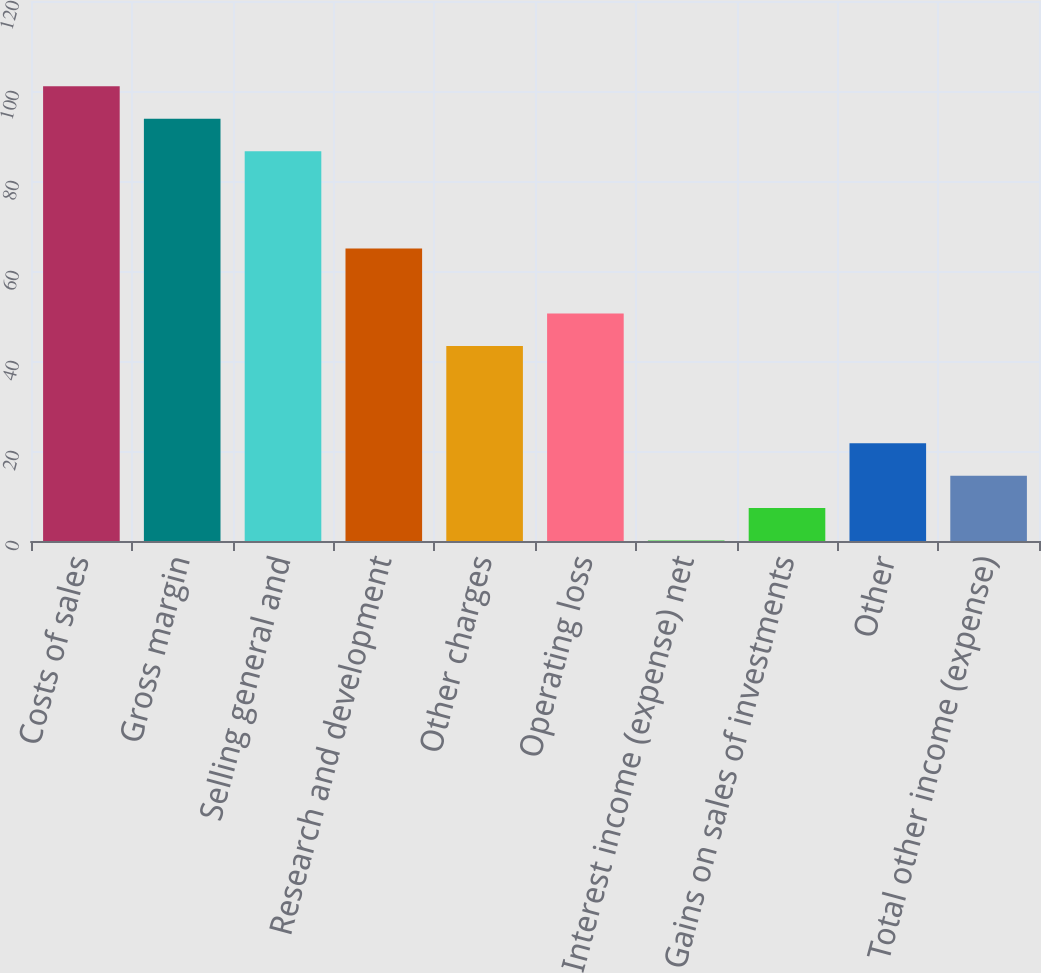Convert chart. <chart><loc_0><loc_0><loc_500><loc_500><bar_chart><fcel>Costs of sales<fcel>Gross margin<fcel>Selling general and<fcel>Research and development<fcel>Other charges<fcel>Operating loss<fcel>Interest income (expense) net<fcel>Gains on sales of investments<fcel>Other<fcel>Total other income (expense)<nl><fcel>101.04<fcel>93.83<fcel>86.62<fcel>64.99<fcel>43.36<fcel>50.57<fcel>0.1<fcel>7.31<fcel>21.73<fcel>14.52<nl></chart> 